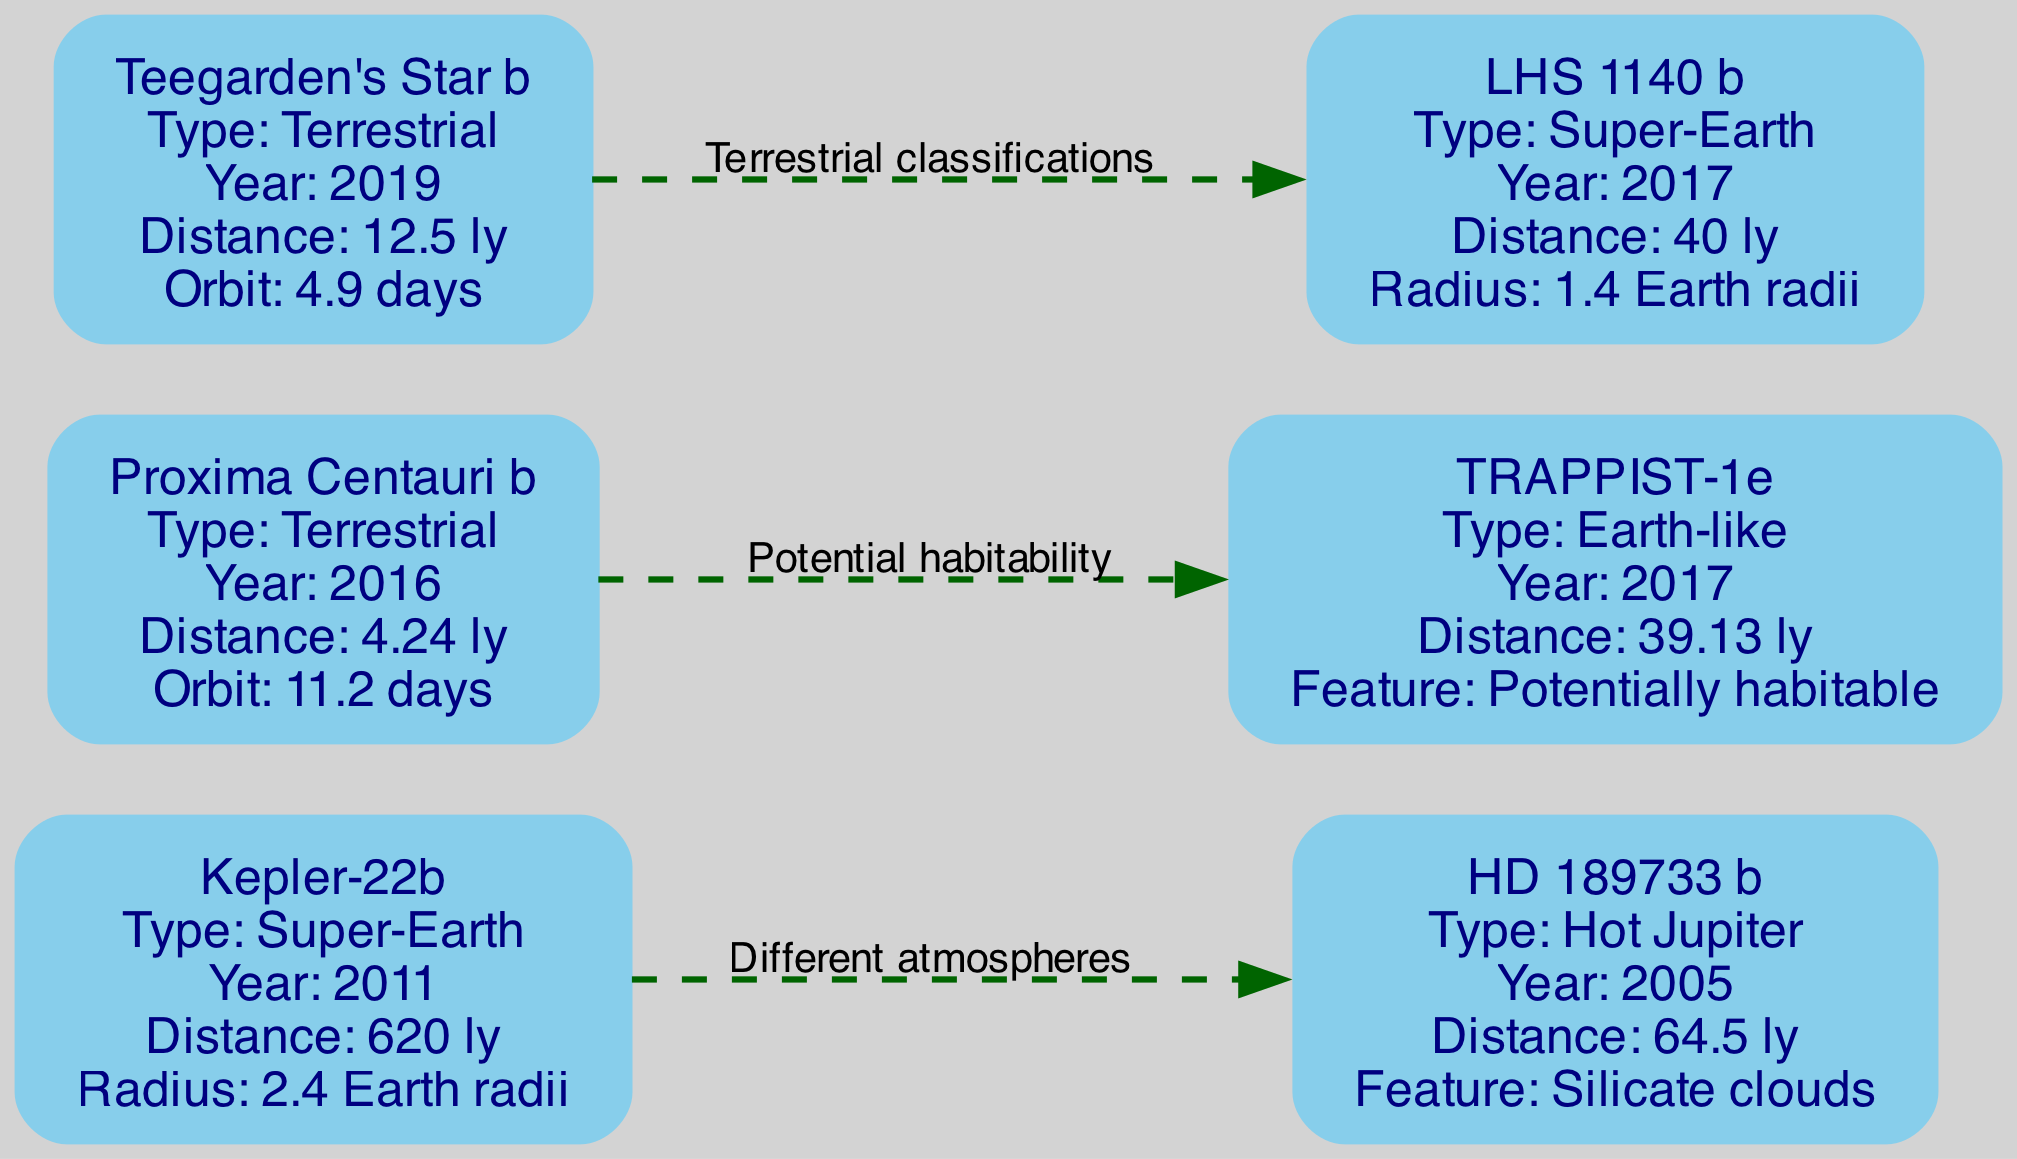What types of exoplanets are represented in the diagram? The diagram includes three types of exoplanets: Super-Earth, Hot Jupiter, and Terrestrial. Each planet is labeled with its type in the node attributes. By identifying the listed planets and their attributes, we can tally the unique types.
Answer: Super-Earth, Hot Jupiter, Terrestrial Which exoplanet has the shortest distance from Earth? The distance values of the exoplanets are noted in light-years. Proxima Centauri b has the shortest distance at 4.24 light-years, which can be found directly from its node attributes.
Answer: 4.24 light-years How many exoplanets were discovered in the year 2017? By scanning the discovery years of the planets listed in the diagram, we identify TRAPPIST-1e and LHS 1140 b both discovered in 2017. Thus, we count the instances of that year in the nodes.
Answer: 2 What notable feature is associated with TRAPPIST-1e? The diagram includes a specific attribute for TRAPPIST-1e stating its notable feature as "Potentially habitable." This can be directly read from the node attributes for TRAPPIST-1e.
Answer: Potentially habitable What is the relationship between Kepler-22b and HD 189733 b? The edges in the diagram denote relationships. There is a labeled edge stating "Different atmospheres" between Kepler-22b and HD 189733 b. This indicates their distinction based on atmospheric conditions.
Answer: Different atmospheres Which exoplanet has the largest radius? Evaluating the radius attributes given in the nodes, Kepler-22b displays a radius of 2.4 Earth radii, which is the largest compared to LHS 1140 b's 1.4 Earth radii.
Answer: 2.4 Earth radii What exoplanet is categorized as a Hot Jupiter? Within the diagram, HD 189733 b is explicitly labeled as a "Hot Jupiter" under its type. This can be directly extracted from its node attributes.
Answer: HD 189733 b What is the orbital period of Teegarden's Star b? The orbital period is listed in the attributes of Teegarden's Star b as "4.9 days." This information can be found in its specific node details.
Answer: 4.9 days Which two exoplanets share a relationship based on potential habitability? The edge between Proxima Centauri b and TRAPPIST-1e is labeled "Potential habitability." By examining the edges, we identify these two planets are related through that theme.
Answer: Proxima Centauri b and TRAPPIST-1e 